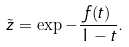Convert formula to latex. <formula><loc_0><loc_0><loc_500><loc_500>\tilde { z } = \exp { - \frac { f ( t ) } { 1 - t } } .</formula> 